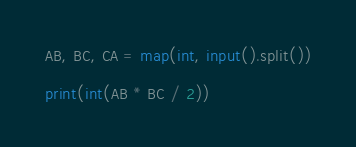<code> <loc_0><loc_0><loc_500><loc_500><_Python_>AB, BC, CA = map(int, input().split())

print(int(AB * BC / 2))

</code> 